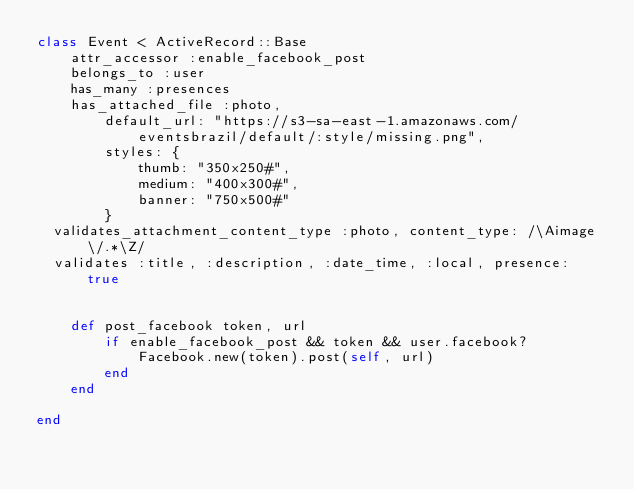<code> <loc_0><loc_0><loc_500><loc_500><_Ruby_>class Event < ActiveRecord::Base
	attr_accessor :enable_facebook_post
	belongs_to :user
	has_many :presences
	has_attached_file :photo, 
		default_url: "https://s3-sa-east-1.amazonaws.com/eventsbrazil/default/:style/missing.png",
		styles: { 
			thumb: "350x250#",
			medium: "400x300#", 
			banner: "750x500#" 
		}
  validates_attachment_content_type :photo, content_type: /\Aimage\/.*\Z/
  validates :title, :description, :date_time, :local, presence: true


	def post_facebook token, url
		if enable_facebook_post && token && user.facebook?
			Facebook.new(token).post(self, url)
		end
	end
	
end
</code> 